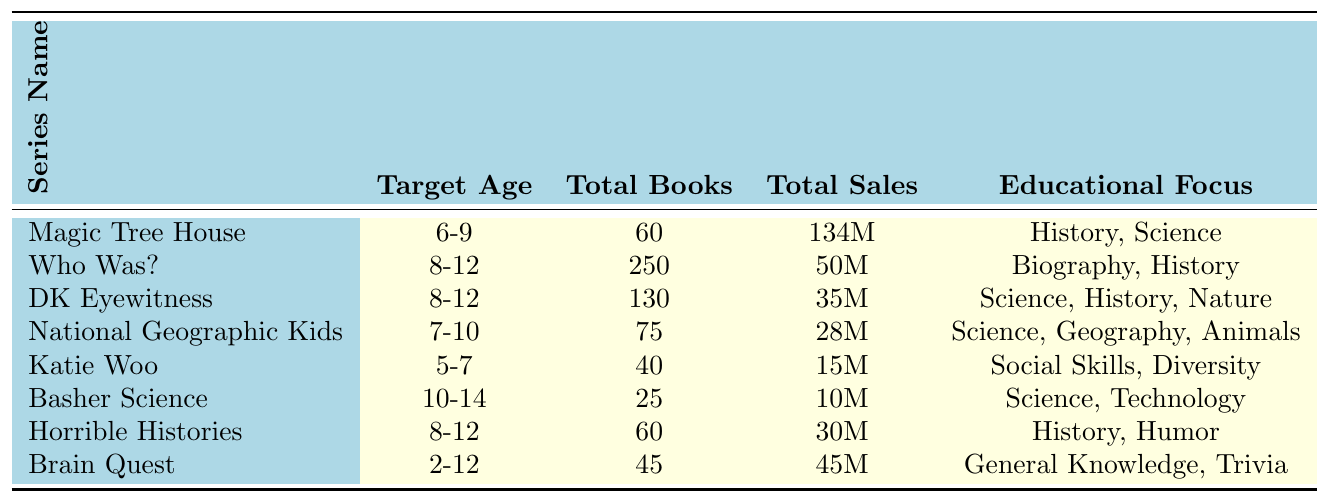What is the highest-selling title in the Magic Tree House series? According to the table, the highest-selling title listed under the Magic Tree House series is "Dinosaurs Before Dark."
Answer: Dinosaurs Before Dark Which series is aimed at the youngest target age group? By looking at the target ages listed, Katie Woo has the lowest minimum age at 5 years old, making it the series aimed at the youngest age group.
Answer: Katie Woo How many total books are there in the Who Was? series? The table shows that the Who Was? series has a total of 250 books.
Answer: 250 books What is the total sales figure for the Basher Science series? The total sales figure for the Basher Science series, as per the table, is 10 million.
Answer: 10 million Which educational focus is common to both National Geographic Kids and DK Eyewitness? Both National Geographic Kids and DK Eyewitness focus on science as part of their educational themes.
Answer: Science What is the average total sales among all listed book series? The total sales figures are: 134M, 50M, 35M, 28M, 15M, 10M, 30M, and 45M. Summing these gives 352M. There are 8 series, so the average is 352M / 8 = 44M.
Answer: 44 million Are there more total books in the Horrible Histories series or the National Geographic Kids series? Horrible Histories has 60 total books, while National Geographic Kids has 75. Therefore, National Geographic Kids has more total books.
Answer: National Geographic Kids What's the total number of books in the Magic Tree House and Katie Woo series combined? The Magic Tree House has 60 books and Katie Woo has 40. Adding these figures gives a total of 60 + 40 = 100 books in both series combined.
Answer: 100 books Which series has the highest total sales and what is that amount? The series with the highest total sales is Magic Tree House with 134 million in sales.
Answer: 134 million Do both the Basher Science and Horrible Histories series focus on science as an educational theme? Basher Science does focus on science, but Horrible Histories focuses on history and humor; thus, it's false to say both series focus on science.
Answer: No 